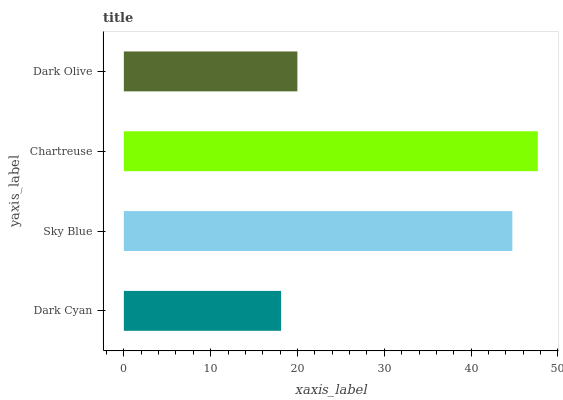Is Dark Cyan the minimum?
Answer yes or no. Yes. Is Chartreuse the maximum?
Answer yes or no. Yes. Is Sky Blue the minimum?
Answer yes or no. No. Is Sky Blue the maximum?
Answer yes or no. No. Is Sky Blue greater than Dark Cyan?
Answer yes or no. Yes. Is Dark Cyan less than Sky Blue?
Answer yes or no. Yes. Is Dark Cyan greater than Sky Blue?
Answer yes or no. No. Is Sky Blue less than Dark Cyan?
Answer yes or no. No. Is Sky Blue the high median?
Answer yes or no. Yes. Is Dark Olive the low median?
Answer yes or no. Yes. Is Chartreuse the high median?
Answer yes or no. No. Is Chartreuse the low median?
Answer yes or no. No. 